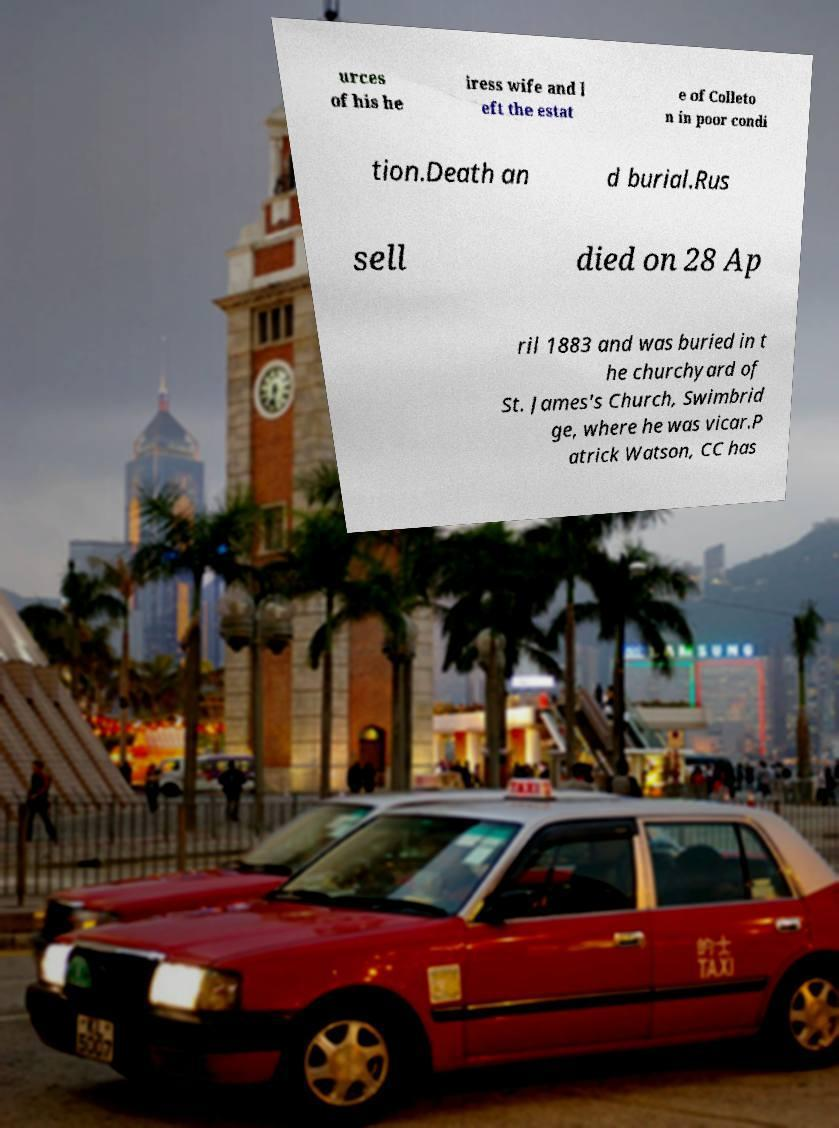Can you accurately transcribe the text from the provided image for me? urces of his he iress wife and l eft the estat e of Colleto n in poor condi tion.Death an d burial.Rus sell died on 28 Ap ril 1883 and was buried in t he churchyard of St. James's Church, Swimbrid ge, where he was vicar.P atrick Watson, CC has 